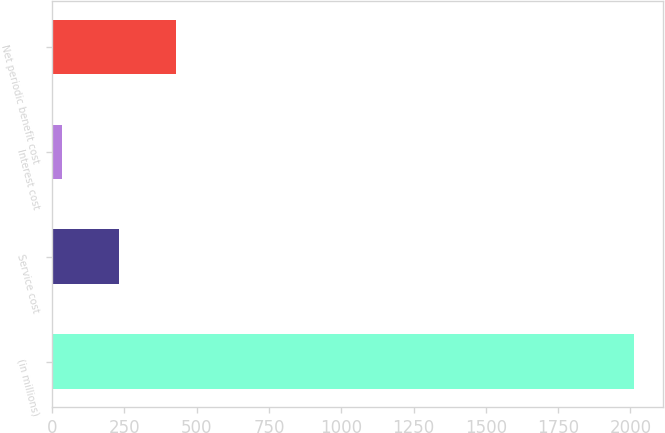Convert chart to OTSL. <chart><loc_0><loc_0><loc_500><loc_500><bar_chart><fcel>(in millions)<fcel>Service cost<fcel>Interest cost<fcel>Net periodic benefit cost<nl><fcel>2012<fcel>231.8<fcel>34<fcel>429.6<nl></chart> 